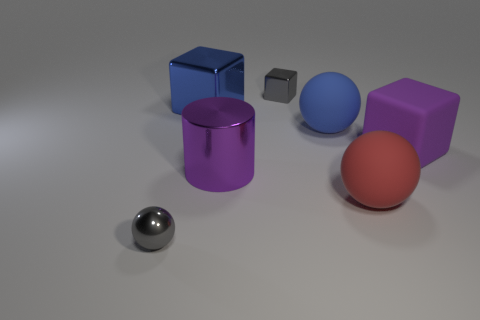There is a gray thing behind the small gray ball; is its shape the same as the red thing?
Provide a succinct answer. No. The metallic object that is the same color as the big matte cube is what size?
Offer a very short reply. Large. Is there a blue shiny cube of the same size as the purple rubber block?
Your response must be concise. Yes. There is a big blue rubber ball that is to the right of the block to the left of the small gray cube; are there any purple objects to the right of it?
Keep it short and to the point. Yes. Does the big shiny cylinder have the same color as the small metal object to the right of the small gray ball?
Your response must be concise. No. What is the material of the small object in front of the large rubber object that is left of the big matte ball that is in front of the big purple block?
Keep it short and to the point. Metal. What is the shape of the large blue thing right of the large blue block?
Give a very brief answer. Sphere. What is the size of the blue thing that is the same material as the large red thing?
Your answer should be very brief. Large. How many big blue things are the same shape as the red rubber thing?
Provide a succinct answer. 1. There is a large block in front of the blue metal block; is it the same color as the large metallic cylinder?
Offer a very short reply. Yes. 